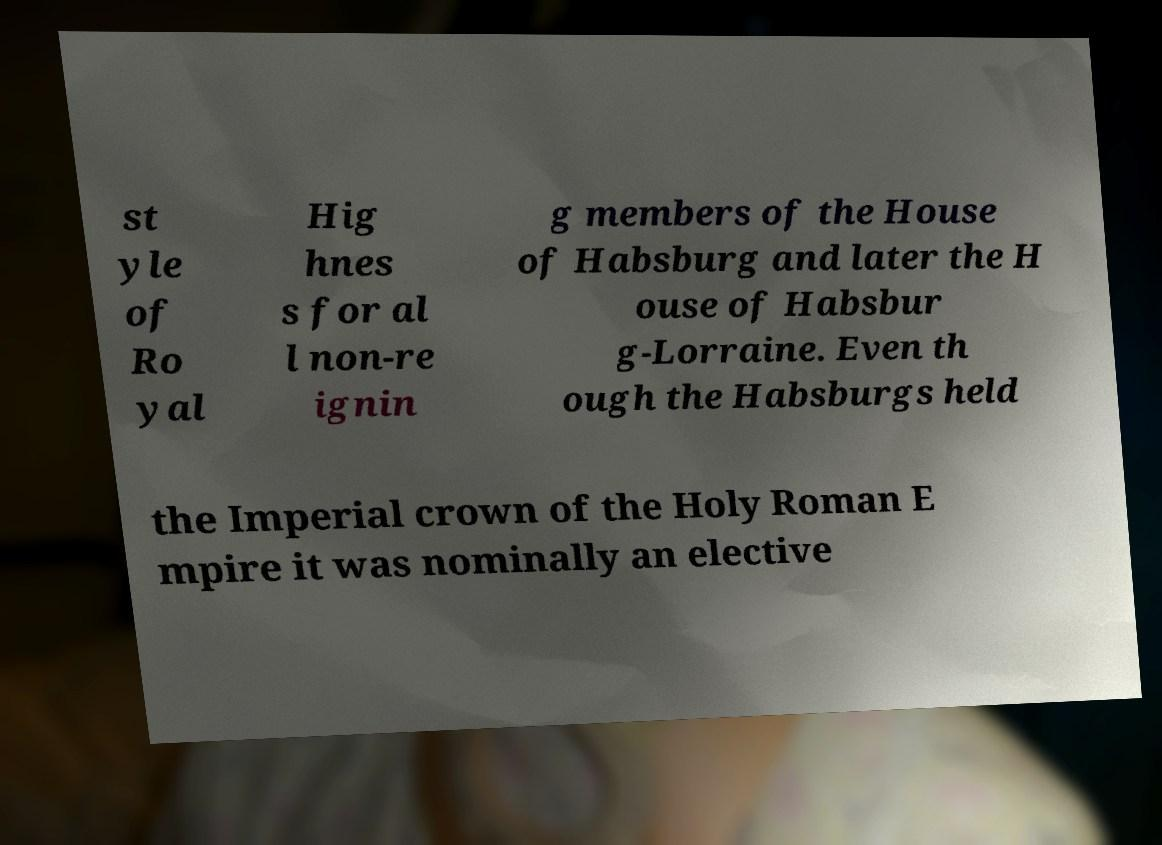Could you assist in decoding the text presented in this image and type it out clearly? st yle of Ro yal Hig hnes s for al l non-re ignin g members of the House of Habsburg and later the H ouse of Habsbur g-Lorraine. Even th ough the Habsburgs held the Imperial crown of the Holy Roman E mpire it was nominally an elective 